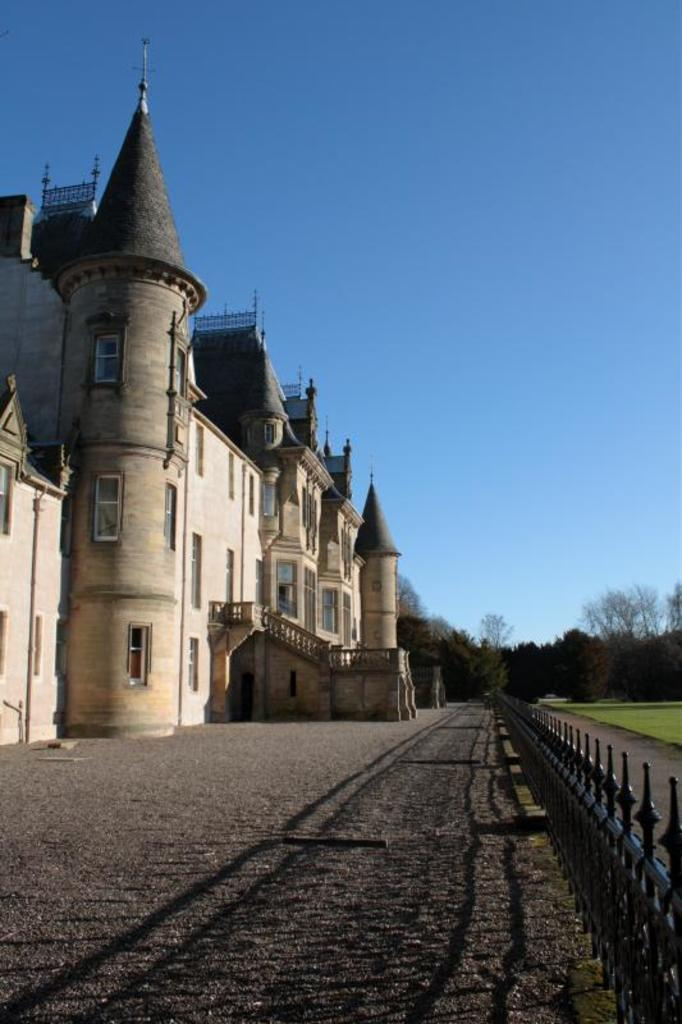What type of building is in the picture? There is a Disney land building in the picture. What features can be seen on the building? The building has windows and glasses. What is located near the building? There is a path and a railing near the building. What can be seen in the background of the picture? There are trees and the sky visible in the background of the picture. What languages are spoken by the books near the building? There are no books present in the image, so it is not possible to determine what languages they might be in. 